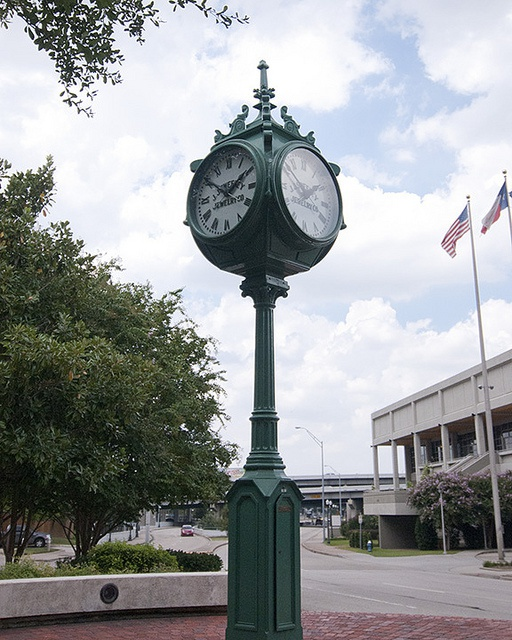Describe the objects in this image and their specific colors. I can see clock in darkgray, gray, and black tones, clock in darkgray and lightgray tones, car in darkgray, black, and gray tones, car in darkgray, gray, and lightgray tones, and car in darkgray, black, and gray tones in this image. 